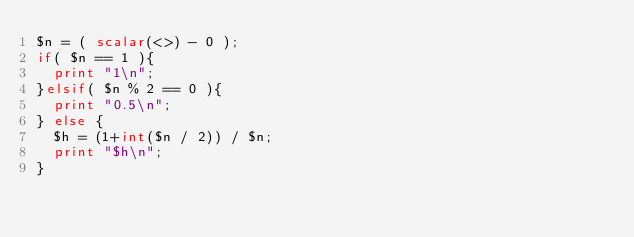Convert code to text. <code><loc_0><loc_0><loc_500><loc_500><_Perl_>$n = ( scalar(<>) - 0 );
if( $n == 1 ){
  print "1\n";
}elsif( $n % 2 == 0 ){
  print "0.5\n";
} else {
  $h = (1+int($n / 2)) / $n;
  print "$h\n";
}
</code> 